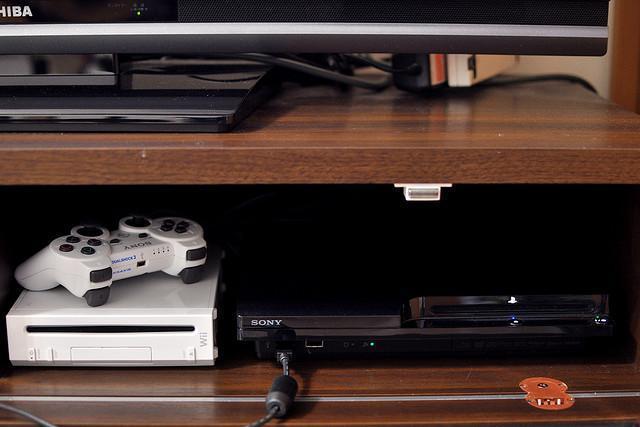How many shelves are in the photo?
Give a very brief answer. 2. How many elephant tails are showing?
Give a very brief answer. 0. 